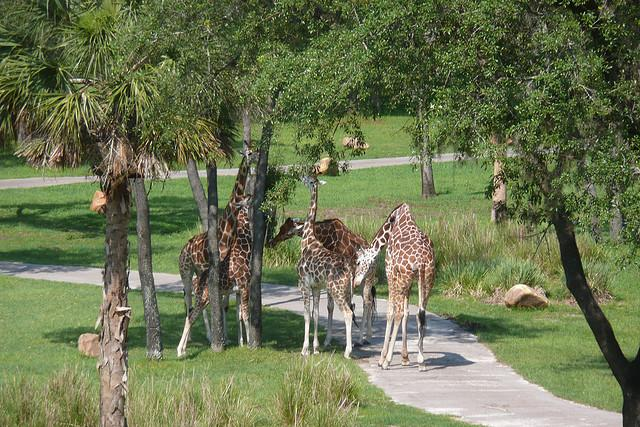Where are these animals most likely to be found in their natural habitat?

Choices:
A) russia
B) new brunswick
C) new york
D) africa africa 